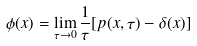<formula> <loc_0><loc_0><loc_500><loc_500>\phi ( x ) = \lim _ { \tau \to 0 } \frac { 1 } { \tau } [ p ( x , \tau ) - \delta ( x ) ]</formula> 